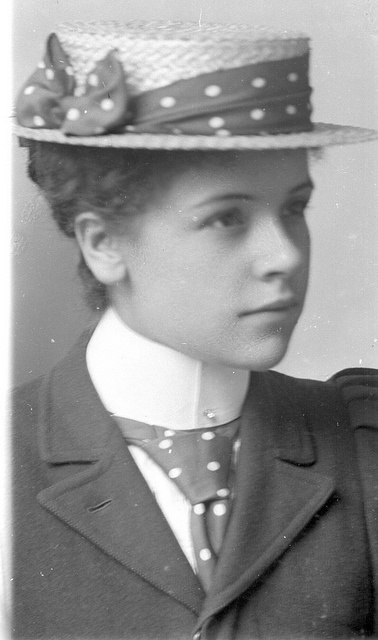Describe the objects in this image and their specific colors. I can see people in gray, white, darkgray, lightgray, and black tones and tie in white, darkgray, gray, lightgray, and black tones in this image. 